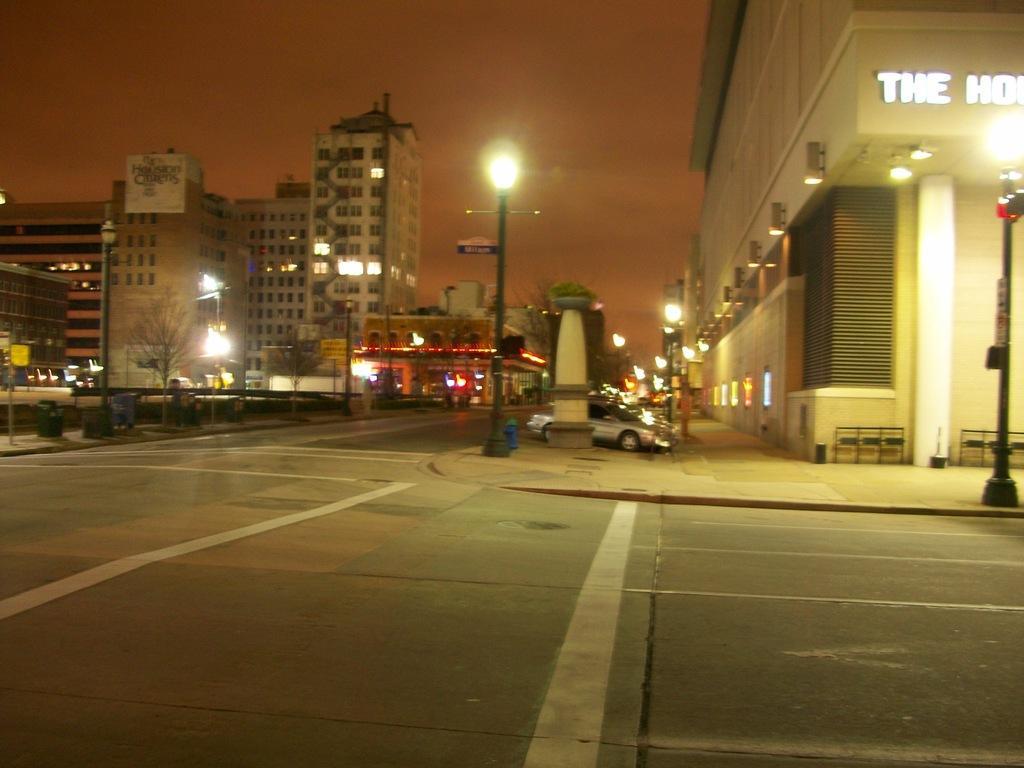In one or two sentences, can you explain what this image depicts? As we can see in the image there are buildings, street lamps, cars, tree and sky. The image is little dark. 